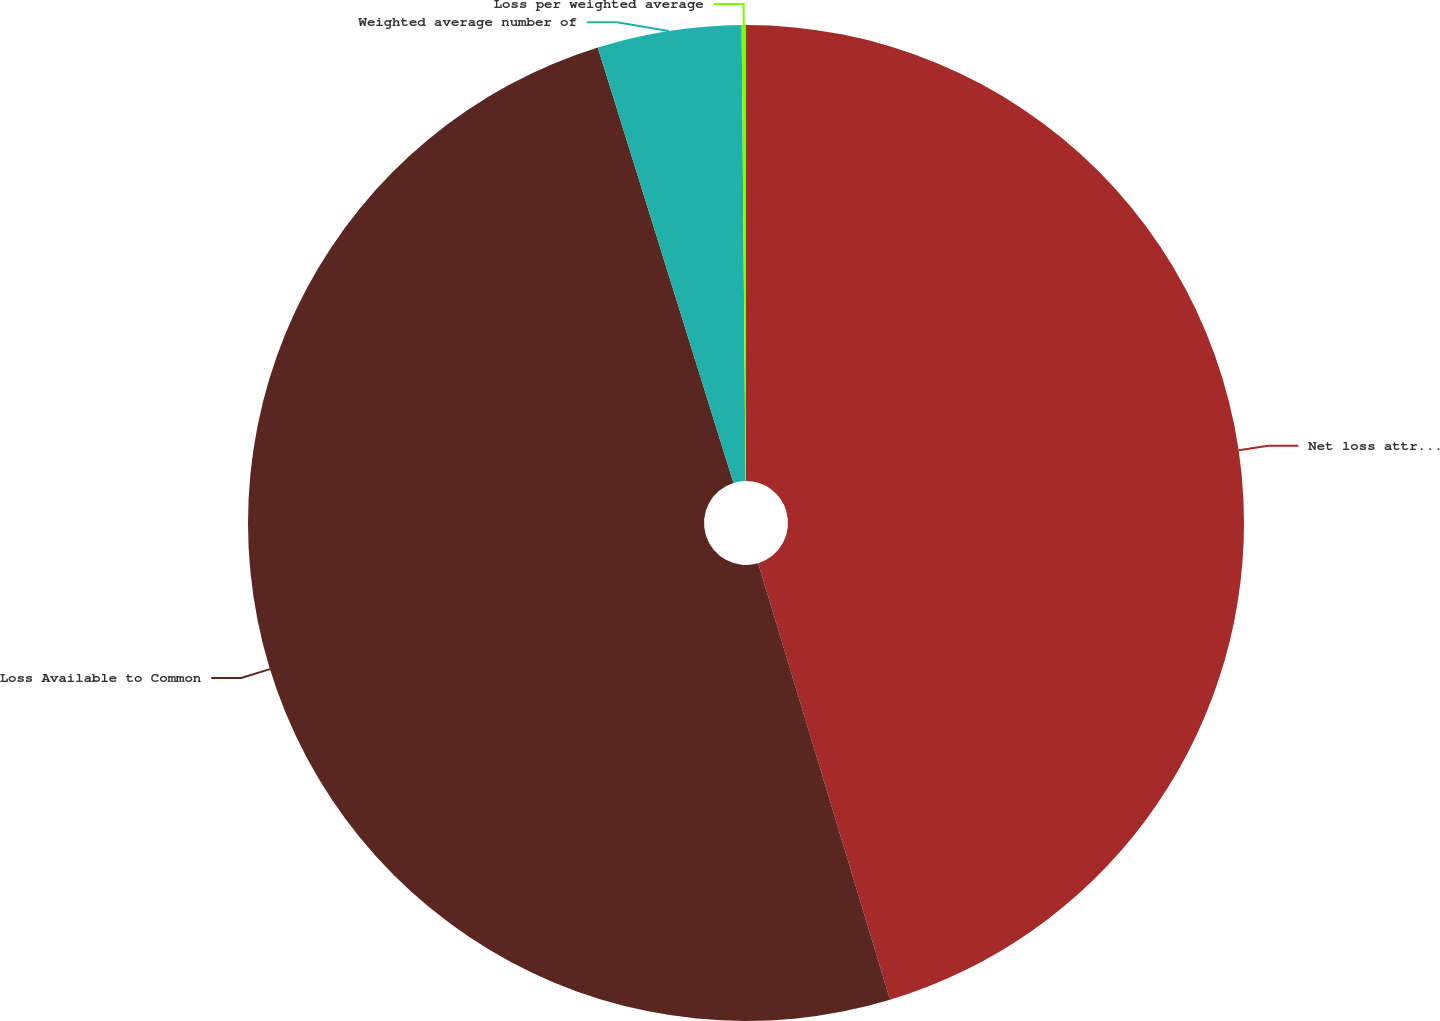Convert chart. <chart><loc_0><loc_0><loc_500><loc_500><pie_chart><fcel>Net loss attributable to NRG<fcel>Loss Available to Common<fcel>Weighted average number of<fcel>Loss per weighted average<nl><fcel>45.33%<fcel>49.86%<fcel>4.67%<fcel>0.14%<nl></chart> 